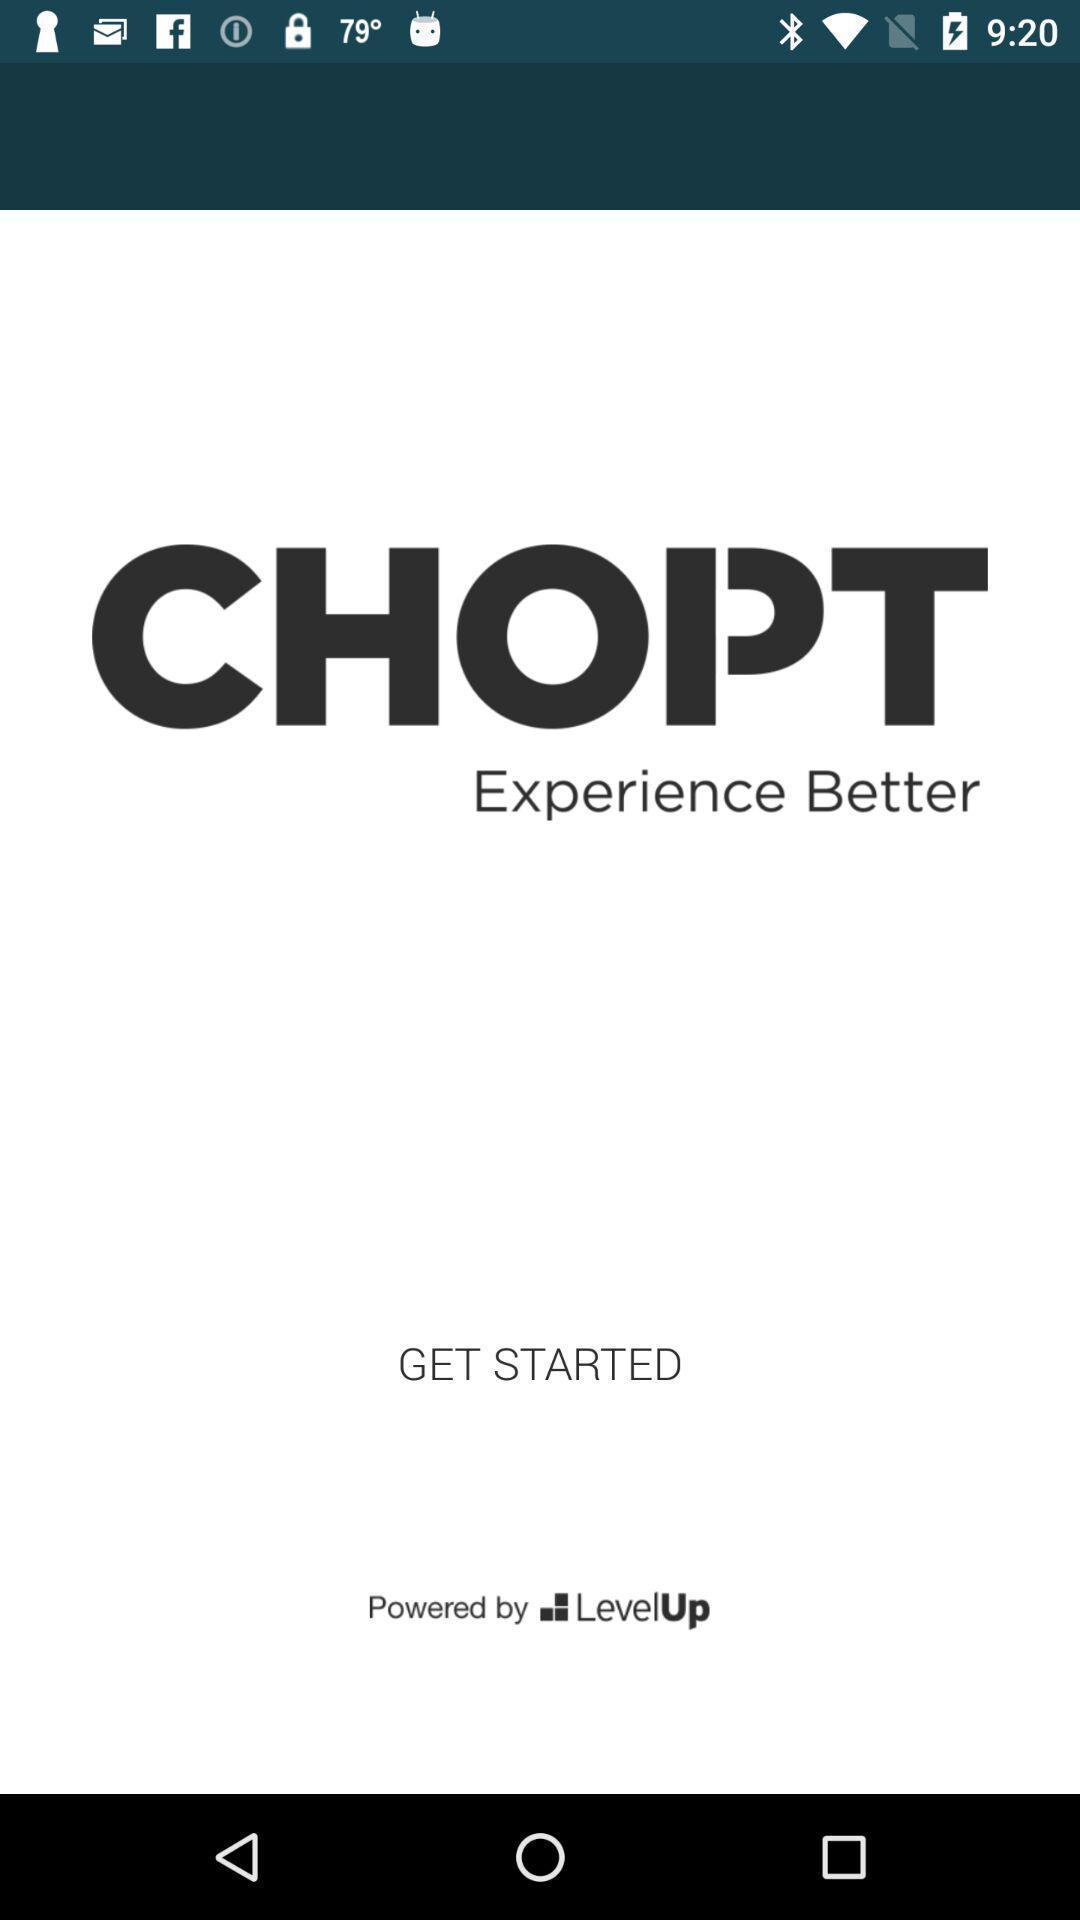Tell me what you see in this picture. Window displaying a food app. 